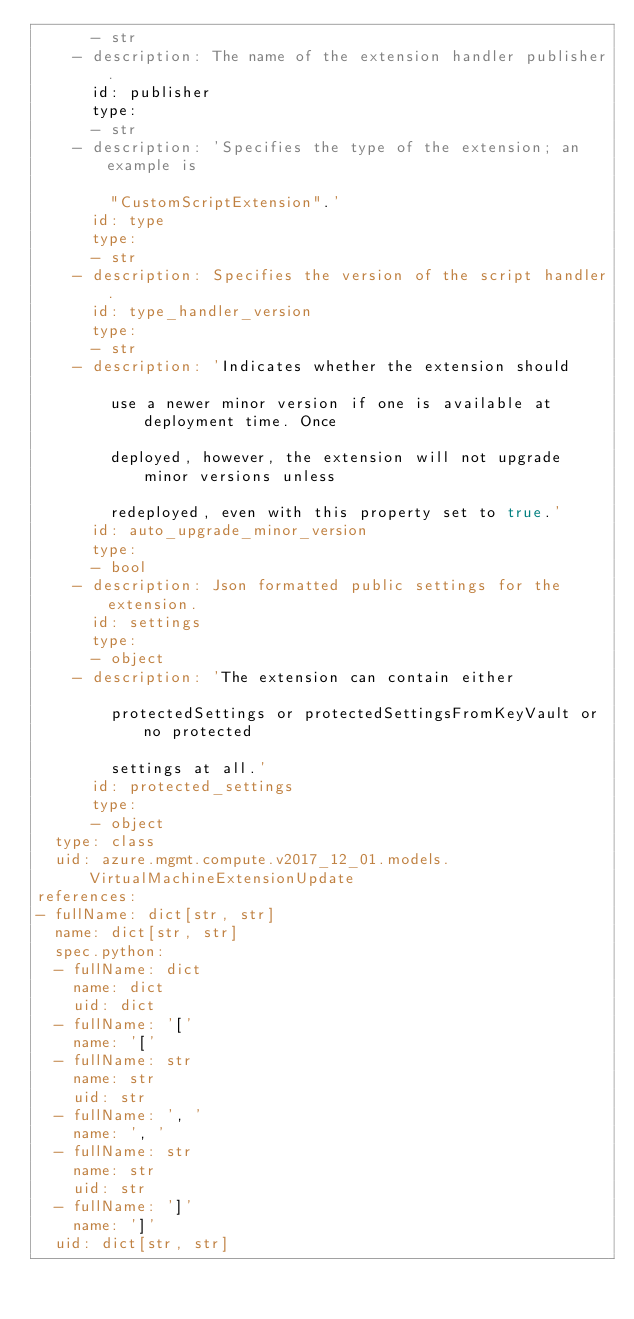Convert code to text. <code><loc_0><loc_0><loc_500><loc_500><_YAML_>      - str
    - description: The name of the extension handler publisher.
      id: publisher
      type:
      - str
    - description: 'Specifies the type of the extension; an example is

        "CustomScriptExtension".'
      id: type
      type:
      - str
    - description: Specifies the version of the script handler.
      id: type_handler_version
      type:
      - str
    - description: 'Indicates whether the extension should

        use a newer minor version if one is available at deployment time. Once

        deployed, however, the extension will not upgrade minor versions unless

        redeployed, even with this property set to true.'
      id: auto_upgrade_minor_version
      type:
      - bool
    - description: Json formatted public settings for the extension.
      id: settings
      type:
      - object
    - description: 'The extension can contain either

        protectedSettings or protectedSettingsFromKeyVault or no protected

        settings at all.'
      id: protected_settings
      type:
      - object
  type: class
  uid: azure.mgmt.compute.v2017_12_01.models.VirtualMachineExtensionUpdate
references:
- fullName: dict[str, str]
  name: dict[str, str]
  spec.python:
  - fullName: dict
    name: dict
    uid: dict
  - fullName: '['
    name: '['
  - fullName: str
    name: str
    uid: str
  - fullName: ', '
    name: ', '
  - fullName: str
    name: str
    uid: str
  - fullName: ']'
    name: ']'
  uid: dict[str, str]
</code> 